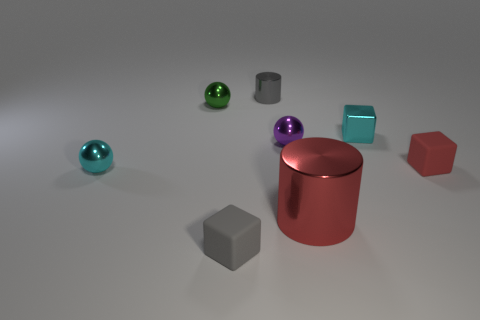Add 1 tiny cyan metallic spheres. How many objects exist? 9 Subtract all blocks. How many objects are left? 5 Subtract 0 blue cylinders. How many objects are left? 8 Subtract all tiny cyan things. Subtract all small purple shiny spheres. How many objects are left? 5 Add 4 tiny gray matte objects. How many tiny gray matte objects are left? 5 Add 4 cyan cylinders. How many cyan cylinders exist? 4 